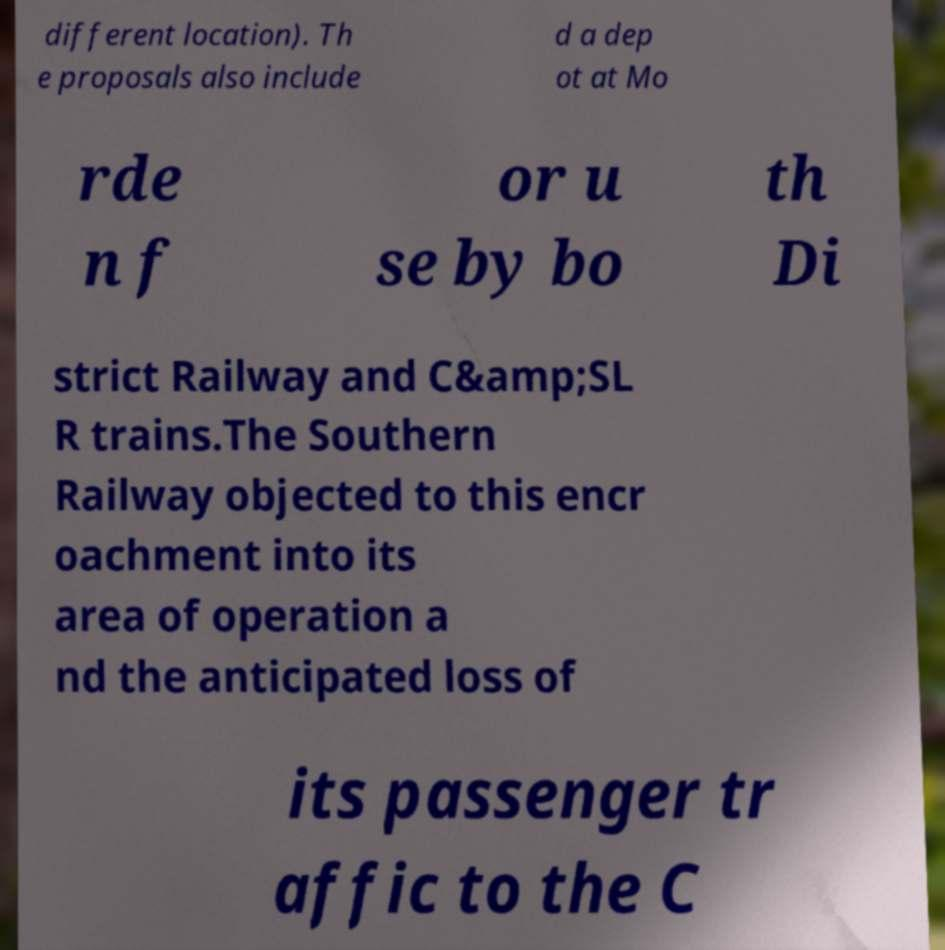What messages or text are displayed in this image? I need them in a readable, typed format. different location). Th e proposals also include d a dep ot at Mo rde n f or u se by bo th Di strict Railway and C&amp;SL R trains.The Southern Railway objected to this encr oachment into its area of operation a nd the anticipated loss of its passenger tr affic to the C 